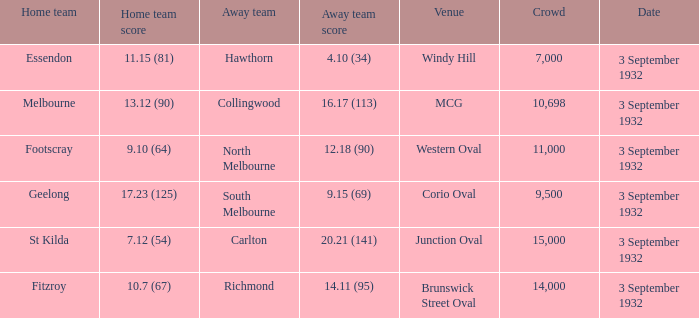What is the Home team score for the Away team of North Melbourne? 9.10 (64). 